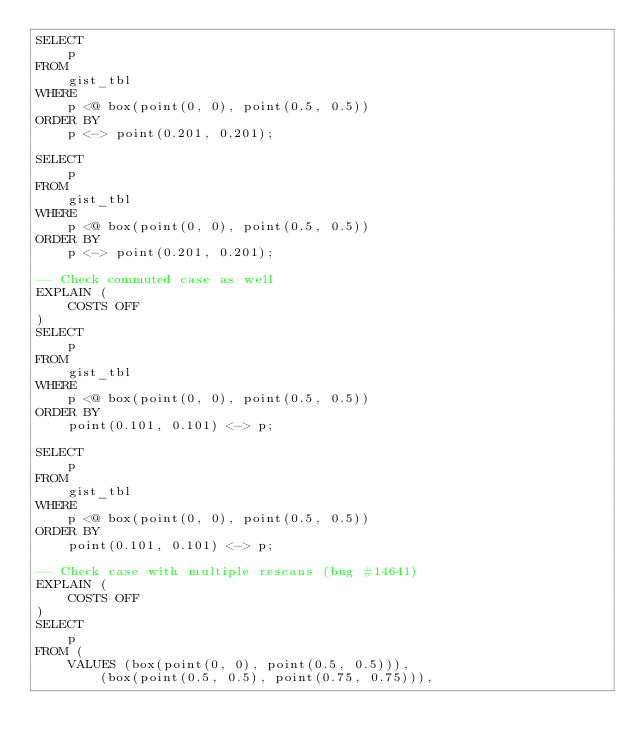Convert code to text. <code><loc_0><loc_0><loc_500><loc_500><_SQL_>SELECT
    p
FROM
    gist_tbl
WHERE
    p <@ box(point(0, 0), point(0.5, 0.5))
ORDER BY
    p <-> point(0.201, 0.201);

SELECT
    p
FROM
    gist_tbl
WHERE
    p <@ box(point(0, 0), point(0.5, 0.5))
ORDER BY
    p <-> point(0.201, 0.201);

-- Check commuted case as well
EXPLAIN (
    COSTS OFF
)
SELECT
    p
FROM
    gist_tbl
WHERE
    p <@ box(point(0, 0), point(0.5, 0.5))
ORDER BY
    point(0.101, 0.101) <-> p;

SELECT
    p
FROM
    gist_tbl
WHERE
    p <@ box(point(0, 0), point(0.5, 0.5))
ORDER BY
    point(0.101, 0.101) <-> p;

-- Check case with multiple rescans (bug #14641)
EXPLAIN (
    COSTS OFF
)
SELECT
    p
FROM (
    VALUES (box(point(0, 0), point(0.5, 0.5))),
        (box(point(0.5, 0.5), point(0.75, 0.75))),</code> 